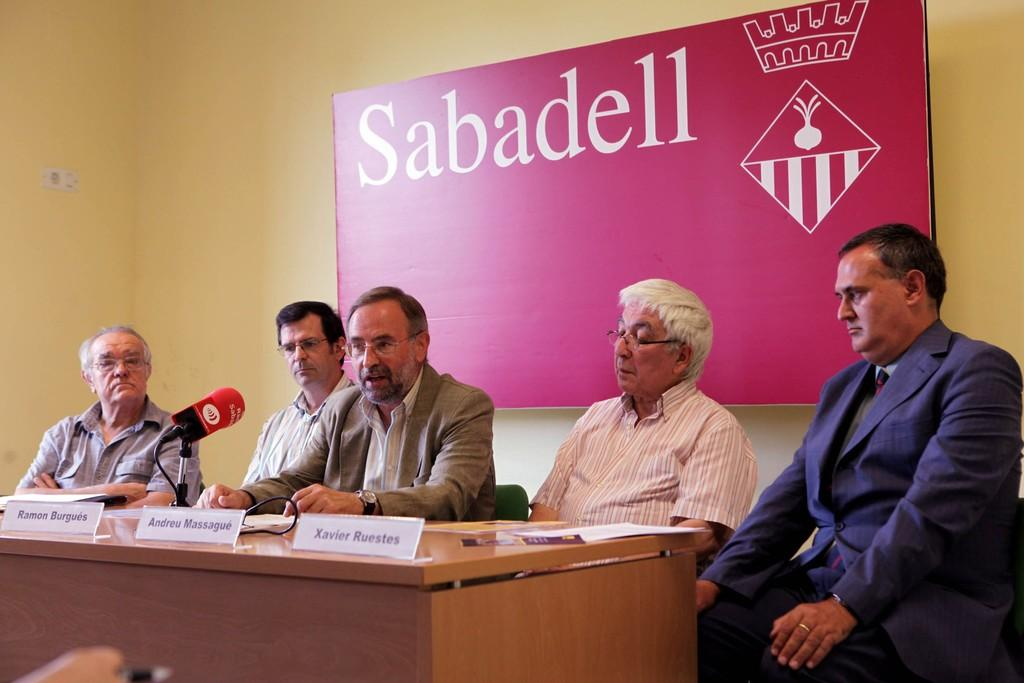What are the people in the image doing? The people in the image are sitting. What objects can be seen related to identification or labeling? There are name boards in the image. What device is present for amplifying sound? There is a microphone in the image. What items can be seen on the table in the image? There are papers on the table in the image. What can be seen on the wall in the background of the image? There is a board on a wall in the background of the image. What type of education is being provided in the image? There is no indication of education being provided in the image. Is there a house visible in the image? There is no house visible in the image. 